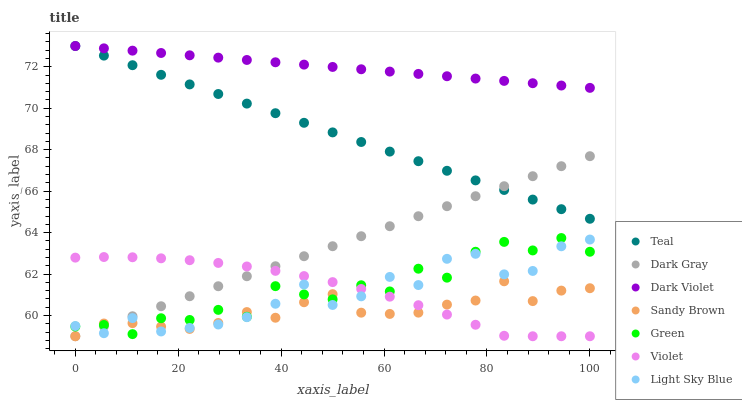Does Sandy Brown have the minimum area under the curve?
Answer yes or no. Yes. Does Dark Violet have the maximum area under the curve?
Answer yes or no. Yes. Does Dark Gray have the minimum area under the curve?
Answer yes or no. No. Does Dark Gray have the maximum area under the curve?
Answer yes or no. No. Is Dark Gray the smoothest?
Answer yes or no. Yes. Is Green the roughest?
Answer yes or no. Yes. Is Light Sky Blue the smoothest?
Answer yes or no. No. Is Light Sky Blue the roughest?
Answer yes or no. No. Does Dark Gray have the lowest value?
Answer yes or no. Yes. Does Light Sky Blue have the lowest value?
Answer yes or no. No. Does Teal have the highest value?
Answer yes or no. Yes. Does Dark Gray have the highest value?
Answer yes or no. No. Is Dark Gray less than Dark Violet?
Answer yes or no. Yes. Is Dark Violet greater than Violet?
Answer yes or no. Yes. Does Sandy Brown intersect Green?
Answer yes or no. Yes. Is Sandy Brown less than Green?
Answer yes or no. No. Is Sandy Brown greater than Green?
Answer yes or no. No. Does Dark Gray intersect Dark Violet?
Answer yes or no. No. 